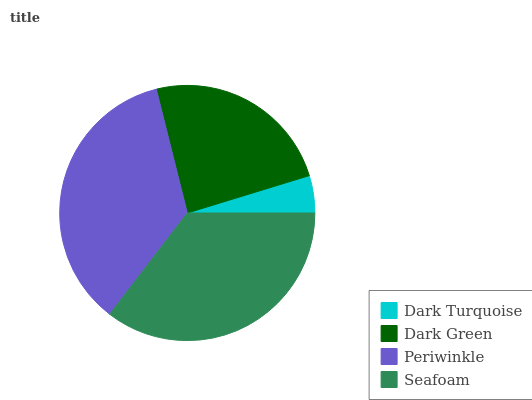Is Dark Turquoise the minimum?
Answer yes or no. Yes. Is Periwinkle the maximum?
Answer yes or no. Yes. Is Dark Green the minimum?
Answer yes or no. No. Is Dark Green the maximum?
Answer yes or no. No. Is Dark Green greater than Dark Turquoise?
Answer yes or no. Yes. Is Dark Turquoise less than Dark Green?
Answer yes or no. Yes. Is Dark Turquoise greater than Dark Green?
Answer yes or no. No. Is Dark Green less than Dark Turquoise?
Answer yes or no. No. Is Seafoam the high median?
Answer yes or no. Yes. Is Dark Green the low median?
Answer yes or no. Yes. Is Dark Turquoise the high median?
Answer yes or no. No. Is Dark Turquoise the low median?
Answer yes or no. No. 